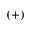<formula> <loc_0><loc_0><loc_500><loc_500>( + )</formula> 